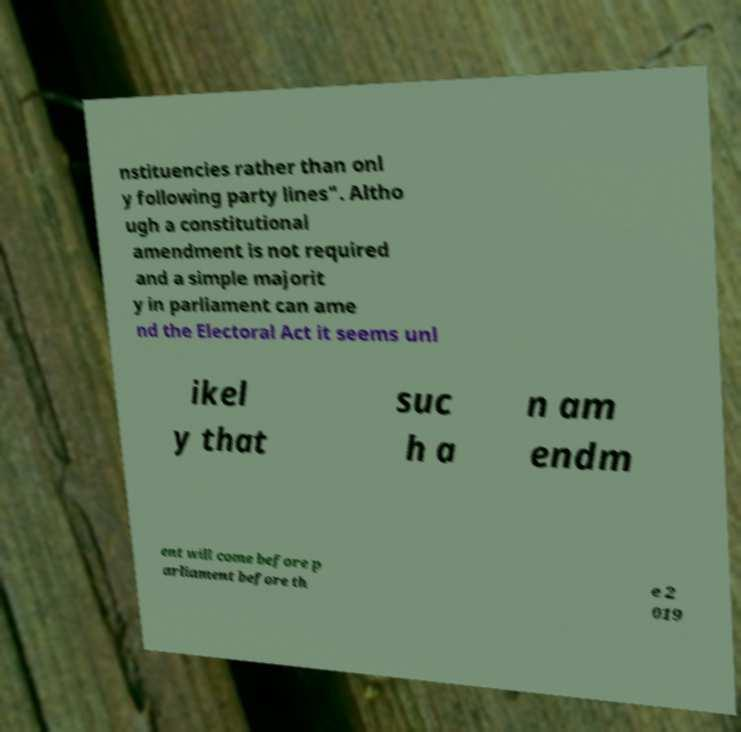Could you assist in decoding the text presented in this image and type it out clearly? nstituencies rather than onl y following party lines". Altho ugh a constitutional amendment is not required and a simple majorit y in parliament can ame nd the Electoral Act it seems unl ikel y that suc h a n am endm ent will come before p arliament before th e 2 019 